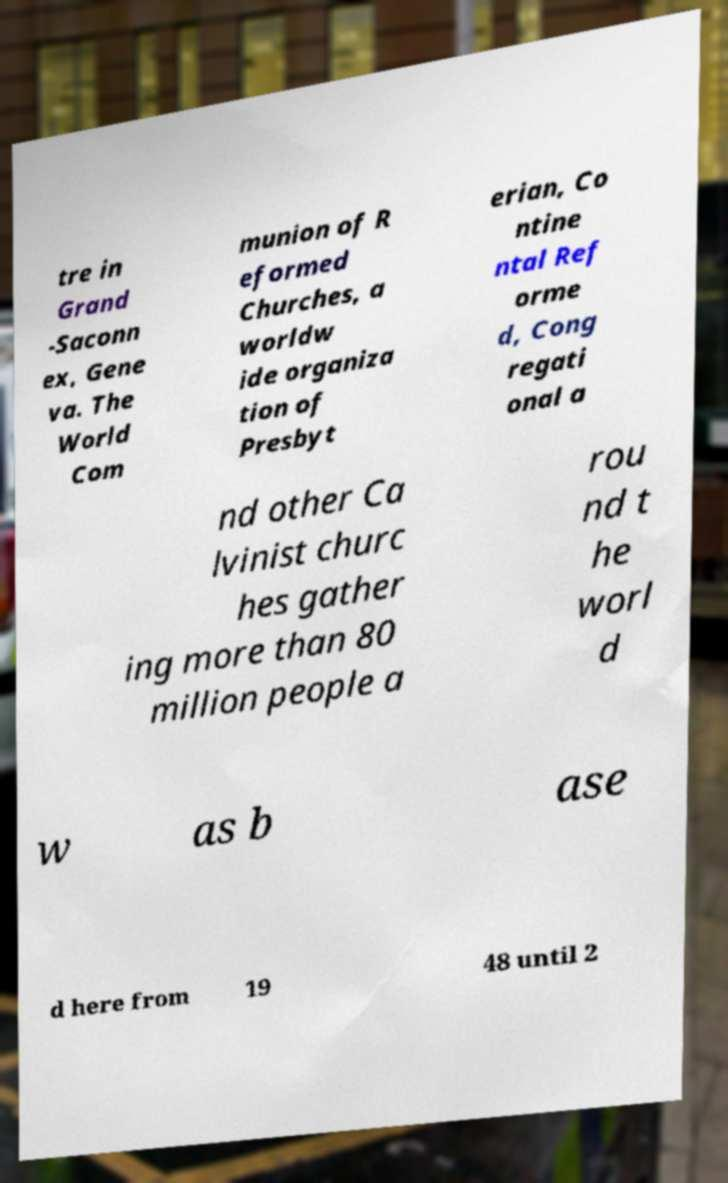What messages or text are displayed in this image? I need them in a readable, typed format. tre in Grand -Saconn ex, Gene va. The World Com munion of R eformed Churches, a worldw ide organiza tion of Presbyt erian, Co ntine ntal Ref orme d, Cong regati onal a nd other Ca lvinist churc hes gather ing more than 80 million people a rou nd t he worl d w as b ase d here from 19 48 until 2 